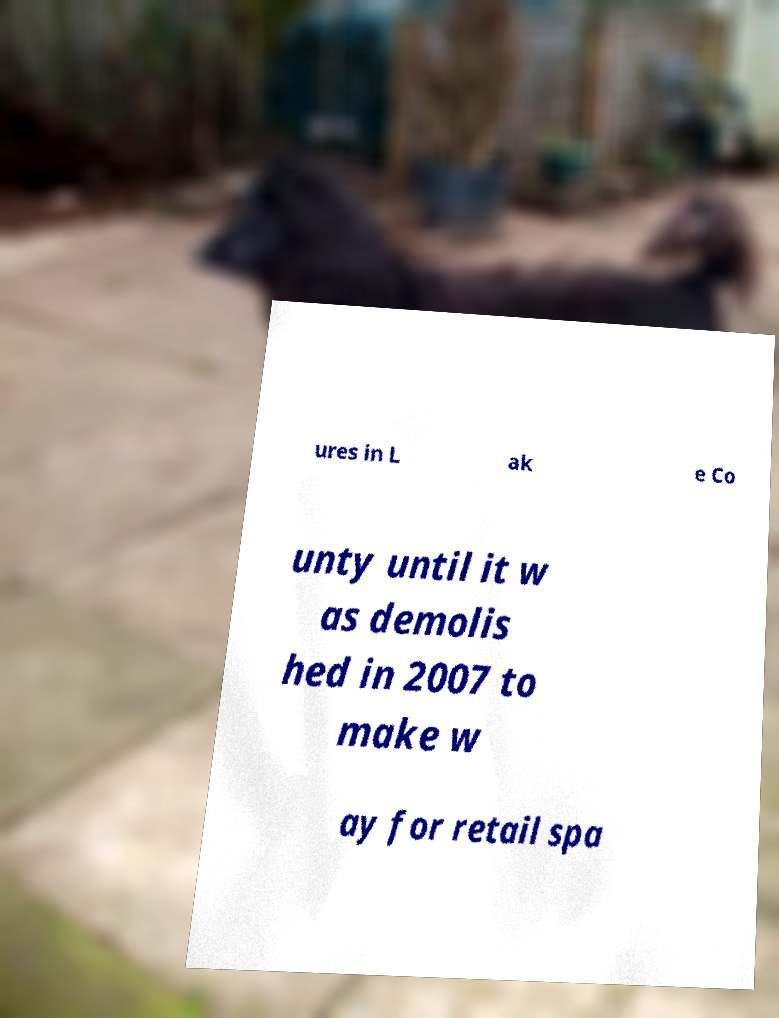Please identify and transcribe the text found in this image. ures in L ak e Co unty until it w as demolis hed in 2007 to make w ay for retail spa 